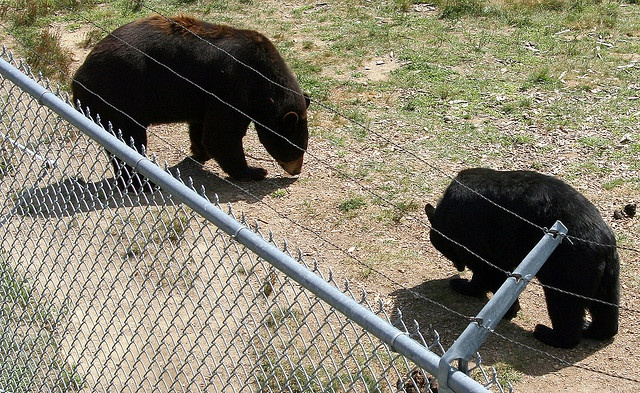Describe the objects in this image and their specific colors. I can see bear in lightgray, black, gray, and maroon tones and bear in lightgray, black, gray, and darkgray tones in this image. 